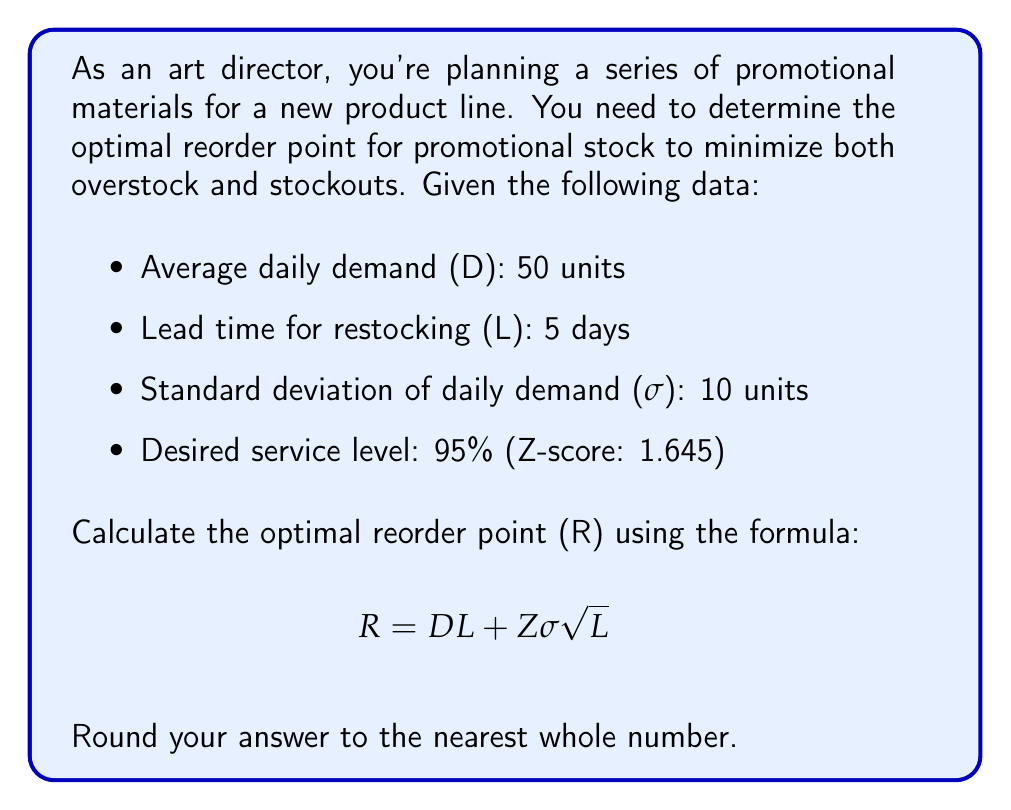Teach me how to tackle this problem. To solve this problem, we'll use the given formula and substitute the known values:

$$ R = DL + Z\sigma\sqrt{L} $$

Where:
- D = Average daily demand = 50 units
- L = Lead time = 5 days
- σ = Standard deviation of daily demand = 10 units
- Z = Z-score for 95% service level = 1.645

Step 1: Calculate DL (average demand during lead time)
$$ DL = 50 \times 5 = 250 $$

Step 2: Calculate $\sigma\sqrt{L}$ (standard deviation of demand during lead time)
$$ \sigma\sqrt{L} = 10 \times \sqrt{5} \approx 22.36 $$

Step 3: Calculate $Z\sigma\sqrt{L}$ (safety stock)
$$ Z\sigma\sqrt{L} = 1.645 \times 22.36 \approx 36.78 $$

Step 4: Sum the results from steps 1 and 3
$$ R = 250 + 36.78 = 286.78 $$

Step 5: Round to the nearest whole number
$$ R \approx 287 $$

Therefore, the optimal reorder point is 287 units.
Answer: 287 units 